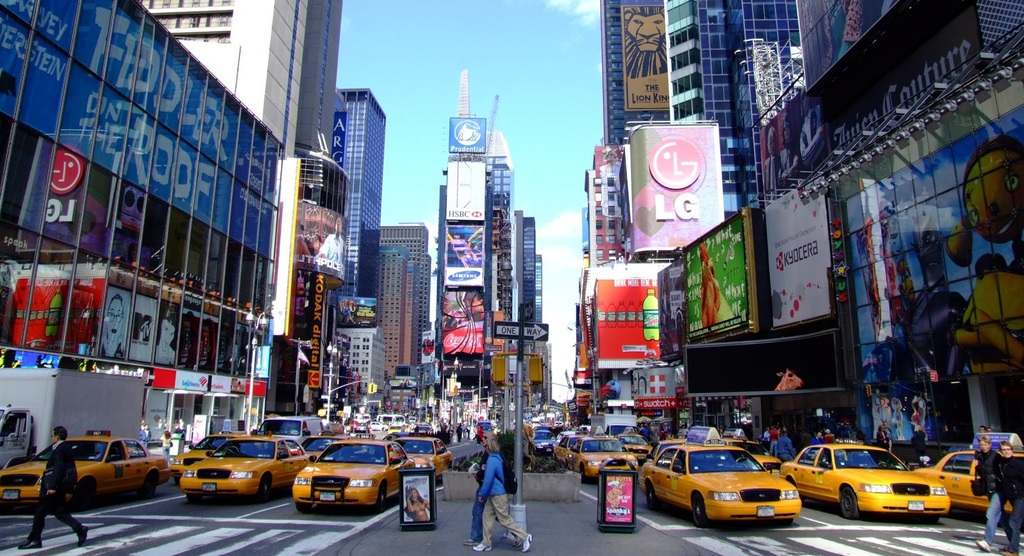What might be the environmental impact of such a busy urban area, shown in this image? Areas like this, with heavy traffic and numerous electronic billboards, contribute significantly to air and light pollution. The concentration of cars suggests substantial emissions, while the brightly lit signs impact the natural light levels in the area. How could this area be improved to reduce its environmental footprint? Implementing stricter emissions regulations for vehicles, transitioning to electric taxis, and installing energy-efficient LED screens for advertisements could significantly mitigate the environmental impact of such bustling urban centers. 